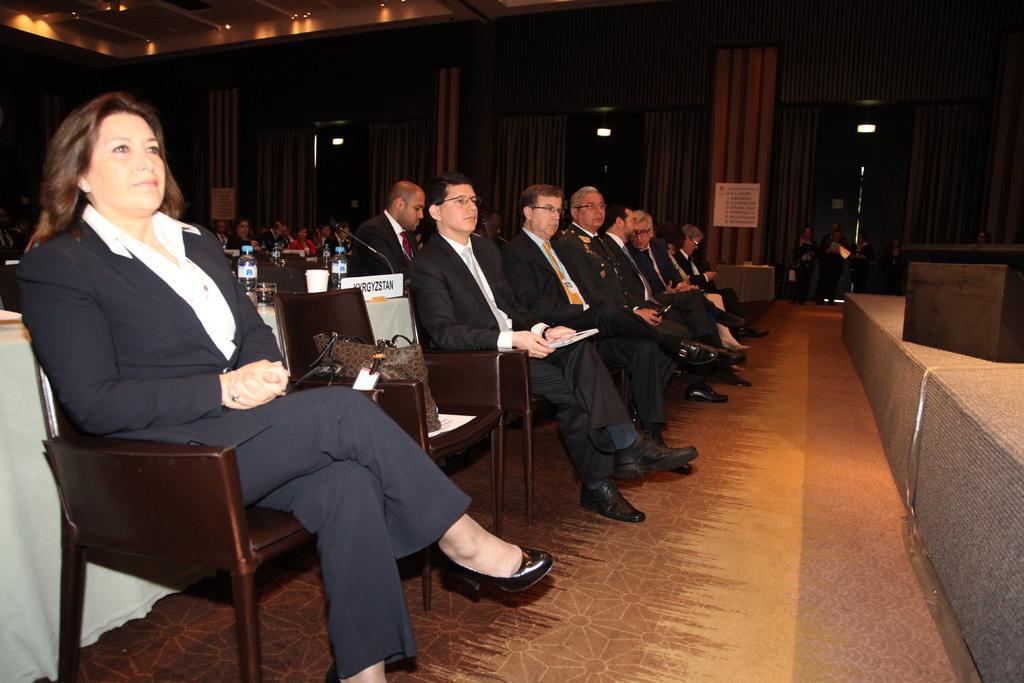Could you give a brief overview of what you see in this image? In the image we can see there are people who are standing on chairs. 